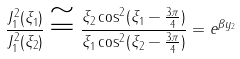<formula> <loc_0><loc_0><loc_500><loc_500>\frac { J _ { 1 } ^ { 2 } ( \xi _ { 1 } ) } { J _ { 1 } ^ { 2 } ( \xi _ { 2 } ) } \cong \frac { \xi _ { 2 } \cos ^ { 2 } ( \xi _ { 1 } - \frac { 3 \pi } { 4 } ) } { \xi _ { 1 } \cos ^ { 2 } ( \xi _ { 2 } - \frac { 3 \pi } { 4 } ) } = e ^ { \beta y _ { 2 } }</formula> 